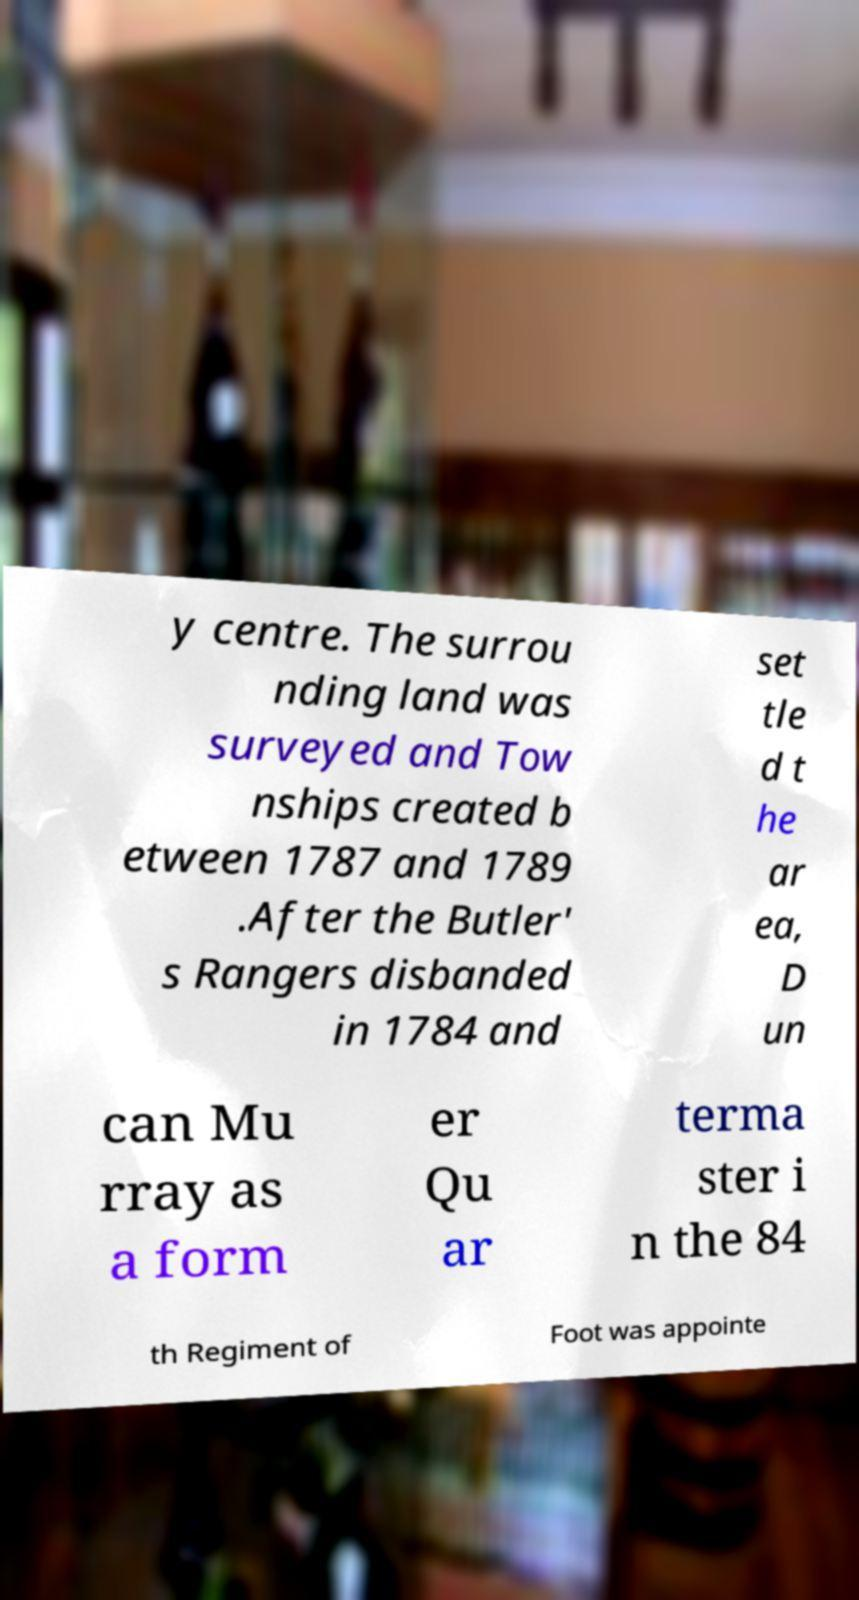Could you extract and type out the text from this image? y centre. The surrou nding land was surveyed and Tow nships created b etween 1787 and 1789 .After the Butler' s Rangers disbanded in 1784 and set tle d t he ar ea, D un can Mu rray as a form er Qu ar terma ster i n the 84 th Regiment of Foot was appointe 